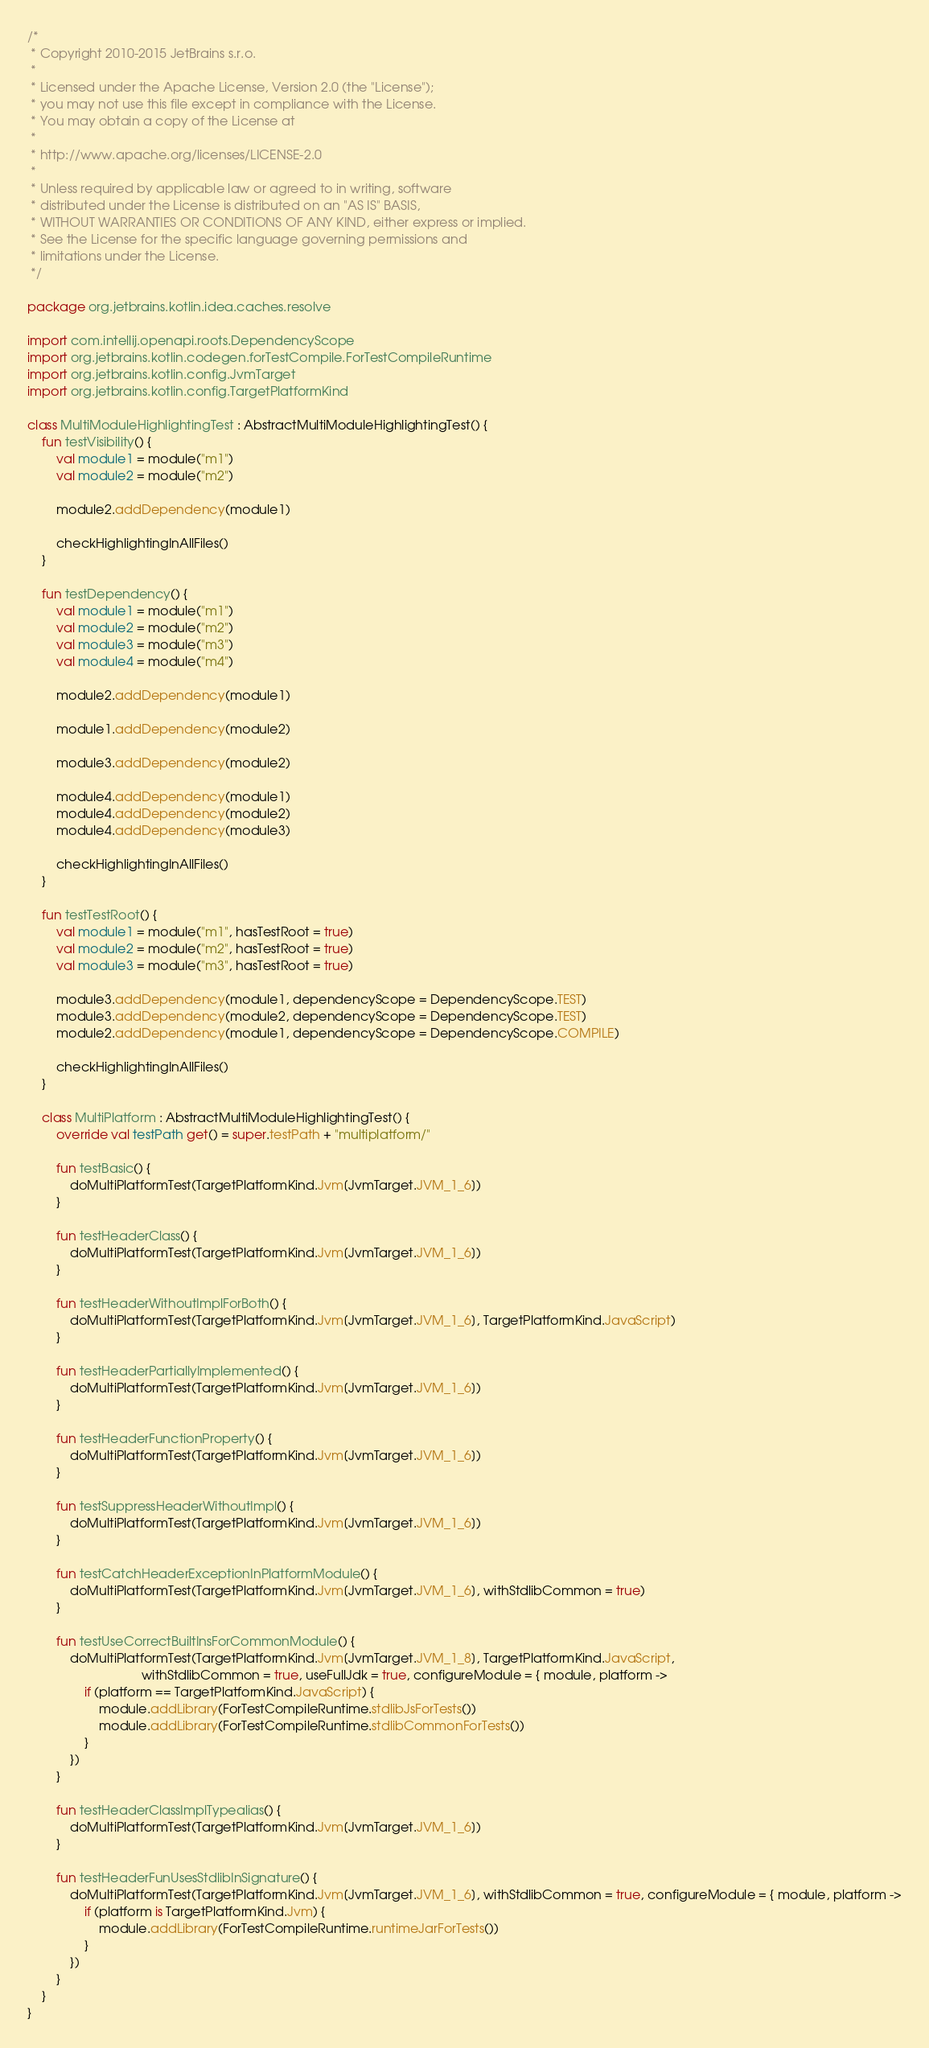<code> <loc_0><loc_0><loc_500><loc_500><_Kotlin_>/*
 * Copyright 2010-2015 JetBrains s.r.o.
 *
 * Licensed under the Apache License, Version 2.0 (the "License");
 * you may not use this file except in compliance with the License.
 * You may obtain a copy of the License at
 *
 * http://www.apache.org/licenses/LICENSE-2.0
 *
 * Unless required by applicable law or agreed to in writing, software
 * distributed under the License is distributed on an "AS IS" BASIS,
 * WITHOUT WARRANTIES OR CONDITIONS OF ANY KIND, either express or implied.
 * See the License for the specific language governing permissions and
 * limitations under the License.
 */

package org.jetbrains.kotlin.idea.caches.resolve

import com.intellij.openapi.roots.DependencyScope
import org.jetbrains.kotlin.codegen.forTestCompile.ForTestCompileRuntime
import org.jetbrains.kotlin.config.JvmTarget
import org.jetbrains.kotlin.config.TargetPlatformKind

class MultiModuleHighlightingTest : AbstractMultiModuleHighlightingTest() {
    fun testVisibility() {
        val module1 = module("m1")
        val module2 = module("m2")

        module2.addDependency(module1)

        checkHighlightingInAllFiles()
    }

    fun testDependency() {
        val module1 = module("m1")
        val module2 = module("m2")
        val module3 = module("m3")
        val module4 = module("m4")

        module2.addDependency(module1)

        module1.addDependency(module2)

        module3.addDependency(module2)

        module4.addDependency(module1)
        module4.addDependency(module2)
        module4.addDependency(module3)

        checkHighlightingInAllFiles()
    }

    fun testTestRoot() {
        val module1 = module("m1", hasTestRoot = true)
        val module2 = module("m2", hasTestRoot = true)
        val module3 = module("m3", hasTestRoot = true)

        module3.addDependency(module1, dependencyScope = DependencyScope.TEST)
        module3.addDependency(module2, dependencyScope = DependencyScope.TEST)
        module2.addDependency(module1, dependencyScope = DependencyScope.COMPILE)

        checkHighlightingInAllFiles()
    }

    class MultiPlatform : AbstractMultiModuleHighlightingTest() {
        override val testPath get() = super.testPath + "multiplatform/"

        fun testBasic() {
            doMultiPlatformTest(TargetPlatformKind.Jvm[JvmTarget.JVM_1_6])
        }

        fun testHeaderClass() {
            doMultiPlatformTest(TargetPlatformKind.Jvm[JvmTarget.JVM_1_6])
        }

        fun testHeaderWithoutImplForBoth() {
            doMultiPlatformTest(TargetPlatformKind.Jvm[JvmTarget.JVM_1_6], TargetPlatformKind.JavaScript)
        }

        fun testHeaderPartiallyImplemented() {
            doMultiPlatformTest(TargetPlatformKind.Jvm[JvmTarget.JVM_1_6])
        }

        fun testHeaderFunctionProperty() {
            doMultiPlatformTest(TargetPlatformKind.Jvm[JvmTarget.JVM_1_6])
        }

        fun testSuppressHeaderWithoutImpl() {
            doMultiPlatformTest(TargetPlatformKind.Jvm[JvmTarget.JVM_1_6])
        }

        fun testCatchHeaderExceptionInPlatformModule() {
            doMultiPlatformTest(TargetPlatformKind.Jvm[JvmTarget.JVM_1_6], withStdlibCommon = true)
        }

        fun testUseCorrectBuiltInsForCommonModule() {
            doMultiPlatformTest(TargetPlatformKind.Jvm[JvmTarget.JVM_1_8], TargetPlatformKind.JavaScript,
                                withStdlibCommon = true, useFullJdk = true, configureModule = { module, platform ->
                if (platform == TargetPlatformKind.JavaScript) {
                    module.addLibrary(ForTestCompileRuntime.stdlibJsForTests())
                    module.addLibrary(ForTestCompileRuntime.stdlibCommonForTests())
                }
            })
        }

        fun testHeaderClassImplTypealias() {
            doMultiPlatformTest(TargetPlatformKind.Jvm[JvmTarget.JVM_1_6])
        }

        fun testHeaderFunUsesStdlibInSignature() {
            doMultiPlatformTest(TargetPlatformKind.Jvm[JvmTarget.JVM_1_6], withStdlibCommon = true, configureModule = { module, platform ->
                if (platform is TargetPlatformKind.Jvm) {
                    module.addLibrary(ForTestCompileRuntime.runtimeJarForTests())
                }
            })
        }
    }
}
</code> 